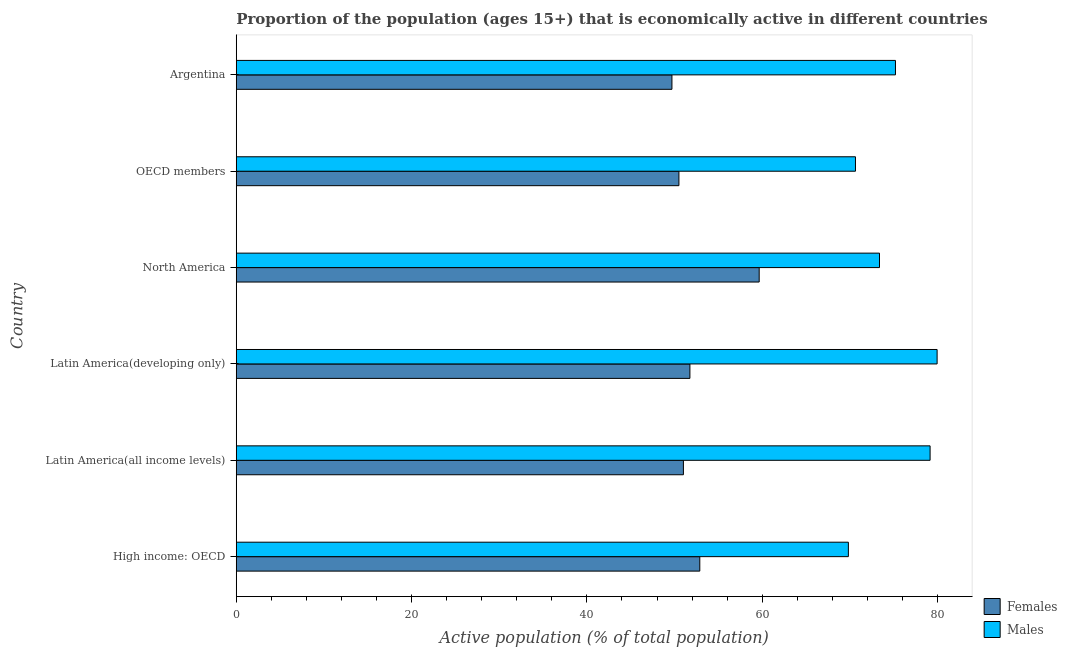How many different coloured bars are there?
Ensure brevity in your answer.  2. How many groups of bars are there?
Offer a very short reply. 6. How many bars are there on the 3rd tick from the top?
Offer a very short reply. 2. What is the label of the 6th group of bars from the top?
Your answer should be compact. High income: OECD. In how many cases, is the number of bars for a given country not equal to the number of legend labels?
Provide a short and direct response. 0. What is the percentage of economically active male population in OECD members?
Make the answer very short. 70.64. Across all countries, what is the maximum percentage of economically active male population?
Provide a succinct answer. 79.95. Across all countries, what is the minimum percentage of economically active female population?
Ensure brevity in your answer.  49.7. In which country was the percentage of economically active male population maximum?
Your answer should be very brief. Latin America(developing only). In which country was the percentage of economically active male population minimum?
Keep it short and to the point. High income: OECD. What is the total percentage of economically active female population in the graph?
Give a very brief answer. 315.49. What is the difference between the percentage of economically active male population in Argentina and that in Latin America(all income levels)?
Offer a very short reply. -3.95. What is the difference between the percentage of economically active male population in Latin America(developing only) and the percentage of economically active female population in Latin America(all income levels)?
Your answer should be very brief. 28.94. What is the average percentage of economically active female population per country?
Keep it short and to the point. 52.58. What is the difference between the percentage of economically active male population and percentage of economically active female population in Latin America(developing only)?
Your response must be concise. 28.2. What is the ratio of the percentage of economically active male population in Latin America(all income levels) to that in OECD members?
Offer a very short reply. 1.12. Is the percentage of economically active female population in Argentina less than that in OECD members?
Keep it short and to the point. Yes. Is the difference between the percentage of economically active female population in Argentina and High income: OECD greater than the difference between the percentage of economically active male population in Argentina and High income: OECD?
Your answer should be very brief. No. What is the difference between the highest and the second highest percentage of economically active male population?
Your answer should be compact. 0.8. What is the difference between the highest and the lowest percentage of economically active male population?
Provide a short and direct response. 10.12. In how many countries, is the percentage of economically active male population greater than the average percentage of economically active male population taken over all countries?
Ensure brevity in your answer.  3. What does the 1st bar from the top in OECD members represents?
Keep it short and to the point. Males. What does the 1st bar from the bottom in Argentina represents?
Your answer should be very brief. Females. How many bars are there?
Make the answer very short. 12. Are all the bars in the graph horizontal?
Offer a terse response. Yes. Are the values on the major ticks of X-axis written in scientific E-notation?
Your answer should be very brief. No. Does the graph contain any zero values?
Ensure brevity in your answer.  No. Does the graph contain grids?
Keep it short and to the point. No. What is the title of the graph?
Your answer should be very brief. Proportion of the population (ages 15+) that is economically active in different countries. What is the label or title of the X-axis?
Your response must be concise. Active population (% of total population). What is the Active population (% of total population) in Females in High income: OECD?
Provide a short and direct response. 52.88. What is the Active population (% of total population) in Males in High income: OECD?
Provide a short and direct response. 69.83. What is the Active population (% of total population) in Females in Latin America(all income levels)?
Provide a short and direct response. 51.01. What is the Active population (% of total population) of Males in Latin America(all income levels)?
Your answer should be very brief. 79.15. What is the Active population (% of total population) in Females in Latin America(developing only)?
Keep it short and to the point. 51.75. What is the Active population (% of total population) in Males in Latin America(developing only)?
Make the answer very short. 79.95. What is the Active population (% of total population) in Females in North America?
Provide a short and direct response. 59.65. What is the Active population (% of total population) of Males in North America?
Ensure brevity in your answer.  73.38. What is the Active population (% of total population) of Females in OECD members?
Make the answer very short. 50.5. What is the Active population (% of total population) in Males in OECD members?
Your answer should be very brief. 70.64. What is the Active population (% of total population) of Females in Argentina?
Offer a very short reply. 49.7. What is the Active population (% of total population) of Males in Argentina?
Your response must be concise. 75.2. Across all countries, what is the maximum Active population (% of total population) of Females?
Your answer should be very brief. 59.65. Across all countries, what is the maximum Active population (% of total population) in Males?
Keep it short and to the point. 79.95. Across all countries, what is the minimum Active population (% of total population) in Females?
Your answer should be very brief. 49.7. Across all countries, what is the minimum Active population (% of total population) in Males?
Make the answer very short. 69.83. What is the total Active population (% of total population) in Females in the graph?
Your answer should be very brief. 315.49. What is the total Active population (% of total population) of Males in the graph?
Make the answer very short. 448.14. What is the difference between the Active population (% of total population) in Females in High income: OECD and that in Latin America(all income levels)?
Offer a very short reply. 1.87. What is the difference between the Active population (% of total population) of Males in High income: OECD and that in Latin America(all income levels)?
Provide a succinct answer. -9.32. What is the difference between the Active population (% of total population) of Females in High income: OECD and that in Latin America(developing only)?
Make the answer very short. 1.13. What is the difference between the Active population (% of total population) of Males in High income: OECD and that in Latin America(developing only)?
Keep it short and to the point. -10.12. What is the difference between the Active population (% of total population) in Females in High income: OECD and that in North America?
Make the answer very short. -6.78. What is the difference between the Active population (% of total population) of Males in High income: OECD and that in North America?
Give a very brief answer. -3.55. What is the difference between the Active population (% of total population) of Females in High income: OECD and that in OECD members?
Your response must be concise. 2.38. What is the difference between the Active population (% of total population) in Males in High income: OECD and that in OECD members?
Your answer should be compact. -0.81. What is the difference between the Active population (% of total population) of Females in High income: OECD and that in Argentina?
Keep it short and to the point. 3.18. What is the difference between the Active population (% of total population) of Males in High income: OECD and that in Argentina?
Keep it short and to the point. -5.37. What is the difference between the Active population (% of total population) in Females in Latin America(all income levels) and that in Latin America(developing only)?
Offer a very short reply. -0.74. What is the difference between the Active population (% of total population) in Males in Latin America(all income levels) and that in Latin America(developing only)?
Ensure brevity in your answer.  -0.8. What is the difference between the Active population (% of total population) in Females in Latin America(all income levels) and that in North America?
Ensure brevity in your answer.  -8.65. What is the difference between the Active population (% of total population) of Males in Latin America(all income levels) and that in North America?
Your answer should be compact. 5.77. What is the difference between the Active population (% of total population) in Females in Latin America(all income levels) and that in OECD members?
Provide a short and direct response. 0.51. What is the difference between the Active population (% of total population) of Males in Latin America(all income levels) and that in OECD members?
Offer a terse response. 8.51. What is the difference between the Active population (% of total population) in Females in Latin America(all income levels) and that in Argentina?
Your answer should be very brief. 1.31. What is the difference between the Active population (% of total population) in Males in Latin America(all income levels) and that in Argentina?
Offer a terse response. 3.95. What is the difference between the Active population (% of total population) of Females in Latin America(developing only) and that in North America?
Offer a very short reply. -7.9. What is the difference between the Active population (% of total population) of Males in Latin America(developing only) and that in North America?
Provide a short and direct response. 6.57. What is the difference between the Active population (% of total population) of Females in Latin America(developing only) and that in OECD members?
Keep it short and to the point. 1.25. What is the difference between the Active population (% of total population) in Males in Latin America(developing only) and that in OECD members?
Offer a very short reply. 9.31. What is the difference between the Active population (% of total population) of Females in Latin America(developing only) and that in Argentina?
Ensure brevity in your answer.  2.05. What is the difference between the Active population (% of total population) in Males in Latin America(developing only) and that in Argentina?
Provide a short and direct response. 4.75. What is the difference between the Active population (% of total population) of Females in North America and that in OECD members?
Provide a short and direct response. 9.16. What is the difference between the Active population (% of total population) in Males in North America and that in OECD members?
Your answer should be very brief. 2.74. What is the difference between the Active population (% of total population) of Females in North America and that in Argentina?
Give a very brief answer. 9.95. What is the difference between the Active population (% of total population) of Males in North America and that in Argentina?
Your response must be concise. -1.82. What is the difference between the Active population (% of total population) in Females in OECD members and that in Argentina?
Your answer should be compact. 0.8. What is the difference between the Active population (% of total population) of Males in OECD members and that in Argentina?
Your answer should be very brief. -4.56. What is the difference between the Active population (% of total population) in Females in High income: OECD and the Active population (% of total population) in Males in Latin America(all income levels)?
Ensure brevity in your answer.  -26.27. What is the difference between the Active population (% of total population) in Females in High income: OECD and the Active population (% of total population) in Males in Latin America(developing only)?
Make the answer very short. -27.07. What is the difference between the Active population (% of total population) in Females in High income: OECD and the Active population (% of total population) in Males in North America?
Your response must be concise. -20.5. What is the difference between the Active population (% of total population) in Females in High income: OECD and the Active population (% of total population) in Males in OECD members?
Provide a short and direct response. -17.76. What is the difference between the Active population (% of total population) of Females in High income: OECD and the Active population (% of total population) of Males in Argentina?
Your response must be concise. -22.32. What is the difference between the Active population (% of total population) in Females in Latin America(all income levels) and the Active population (% of total population) in Males in Latin America(developing only)?
Provide a succinct answer. -28.94. What is the difference between the Active population (% of total population) of Females in Latin America(all income levels) and the Active population (% of total population) of Males in North America?
Ensure brevity in your answer.  -22.37. What is the difference between the Active population (% of total population) in Females in Latin America(all income levels) and the Active population (% of total population) in Males in OECD members?
Your response must be concise. -19.63. What is the difference between the Active population (% of total population) in Females in Latin America(all income levels) and the Active population (% of total population) in Males in Argentina?
Your answer should be compact. -24.19. What is the difference between the Active population (% of total population) of Females in Latin America(developing only) and the Active population (% of total population) of Males in North America?
Your answer should be very brief. -21.63. What is the difference between the Active population (% of total population) of Females in Latin America(developing only) and the Active population (% of total population) of Males in OECD members?
Ensure brevity in your answer.  -18.89. What is the difference between the Active population (% of total population) in Females in Latin America(developing only) and the Active population (% of total population) in Males in Argentina?
Give a very brief answer. -23.45. What is the difference between the Active population (% of total population) in Females in North America and the Active population (% of total population) in Males in OECD members?
Give a very brief answer. -10.98. What is the difference between the Active population (% of total population) of Females in North America and the Active population (% of total population) of Males in Argentina?
Ensure brevity in your answer.  -15.55. What is the difference between the Active population (% of total population) in Females in OECD members and the Active population (% of total population) in Males in Argentina?
Provide a succinct answer. -24.7. What is the average Active population (% of total population) of Females per country?
Ensure brevity in your answer.  52.58. What is the average Active population (% of total population) of Males per country?
Make the answer very short. 74.69. What is the difference between the Active population (% of total population) of Females and Active population (% of total population) of Males in High income: OECD?
Provide a short and direct response. -16.95. What is the difference between the Active population (% of total population) in Females and Active population (% of total population) in Males in Latin America(all income levels)?
Your answer should be very brief. -28.14. What is the difference between the Active population (% of total population) in Females and Active population (% of total population) in Males in Latin America(developing only)?
Ensure brevity in your answer.  -28.2. What is the difference between the Active population (% of total population) in Females and Active population (% of total population) in Males in North America?
Provide a succinct answer. -13.72. What is the difference between the Active population (% of total population) of Females and Active population (% of total population) of Males in OECD members?
Keep it short and to the point. -20.14. What is the difference between the Active population (% of total population) of Females and Active population (% of total population) of Males in Argentina?
Make the answer very short. -25.5. What is the ratio of the Active population (% of total population) in Females in High income: OECD to that in Latin America(all income levels)?
Your answer should be very brief. 1.04. What is the ratio of the Active population (% of total population) of Males in High income: OECD to that in Latin America(all income levels)?
Keep it short and to the point. 0.88. What is the ratio of the Active population (% of total population) in Females in High income: OECD to that in Latin America(developing only)?
Give a very brief answer. 1.02. What is the ratio of the Active population (% of total population) of Males in High income: OECD to that in Latin America(developing only)?
Make the answer very short. 0.87. What is the ratio of the Active population (% of total population) of Females in High income: OECD to that in North America?
Your answer should be compact. 0.89. What is the ratio of the Active population (% of total population) in Males in High income: OECD to that in North America?
Your answer should be compact. 0.95. What is the ratio of the Active population (% of total population) in Females in High income: OECD to that in OECD members?
Your answer should be very brief. 1.05. What is the ratio of the Active population (% of total population) in Males in High income: OECD to that in OECD members?
Offer a terse response. 0.99. What is the ratio of the Active population (% of total population) of Females in High income: OECD to that in Argentina?
Make the answer very short. 1.06. What is the ratio of the Active population (% of total population) of Females in Latin America(all income levels) to that in Latin America(developing only)?
Make the answer very short. 0.99. What is the ratio of the Active population (% of total population) of Females in Latin America(all income levels) to that in North America?
Your response must be concise. 0.86. What is the ratio of the Active population (% of total population) in Males in Latin America(all income levels) to that in North America?
Offer a very short reply. 1.08. What is the ratio of the Active population (% of total population) of Females in Latin America(all income levels) to that in OECD members?
Your answer should be compact. 1.01. What is the ratio of the Active population (% of total population) in Males in Latin America(all income levels) to that in OECD members?
Give a very brief answer. 1.12. What is the ratio of the Active population (% of total population) in Females in Latin America(all income levels) to that in Argentina?
Your answer should be compact. 1.03. What is the ratio of the Active population (% of total population) of Males in Latin America(all income levels) to that in Argentina?
Your response must be concise. 1.05. What is the ratio of the Active population (% of total population) in Females in Latin America(developing only) to that in North America?
Give a very brief answer. 0.87. What is the ratio of the Active population (% of total population) of Males in Latin America(developing only) to that in North America?
Keep it short and to the point. 1.09. What is the ratio of the Active population (% of total population) of Females in Latin America(developing only) to that in OECD members?
Your answer should be very brief. 1.02. What is the ratio of the Active population (% of total population) in Males in Latin America(developing only) to that in OECD members?
Offer a very short reply. 1.13. What is the ratio of the Active population (% of total population) of Females in Latin America(developing only) to that in Argentina?
Your answer should be compact. 1.04. What is the ratio of the Active population (% of total population) in Males in Latin America(developing only) to that in Argentina?
Offer a very short reply. 1.06. What is the ratio of the Active population (% of total population) in Females in North America to that in OECD members?
Provide a short and direct response. 1.18. What is the ratio of the Active population (% of total population) in Males in North America to that in OECD members?
Ensure brevity in your answer.  1.04. What is the ratio of the Active population (% of total population) in Females in North America to that in Argentina?
Your answer should be very brief. 1.2. What is the ratio of the Active population (% of total population) of Males in North America to that in Argentina?
Your answer should be very brief. 0.98. What is the ratio of the Active population (% of total population) of Females in OECD members to that in Argentina?
Provide a short and direct response. 1.02. What is the ratio of the Active population (% of total population) in Males in OECD members to that in Argentina?
Keep it short and to the point. 0.94. What is the difference between the highest and the second highest Active population (% of total population) in Females?
Offer a very short reply. 6.78. What is the difference between the highest and the second highest Active population (% of total population) of Males?
Provide a succinct answer. 0.8. What is the difference between the highest and the lowest Active population (% of total population) in Females?
Give a very brief answer. 9.95. What is the difference between the highest and the lowest Active population (% of total population) in Males?
Your answer should be very brief. 10.12. 